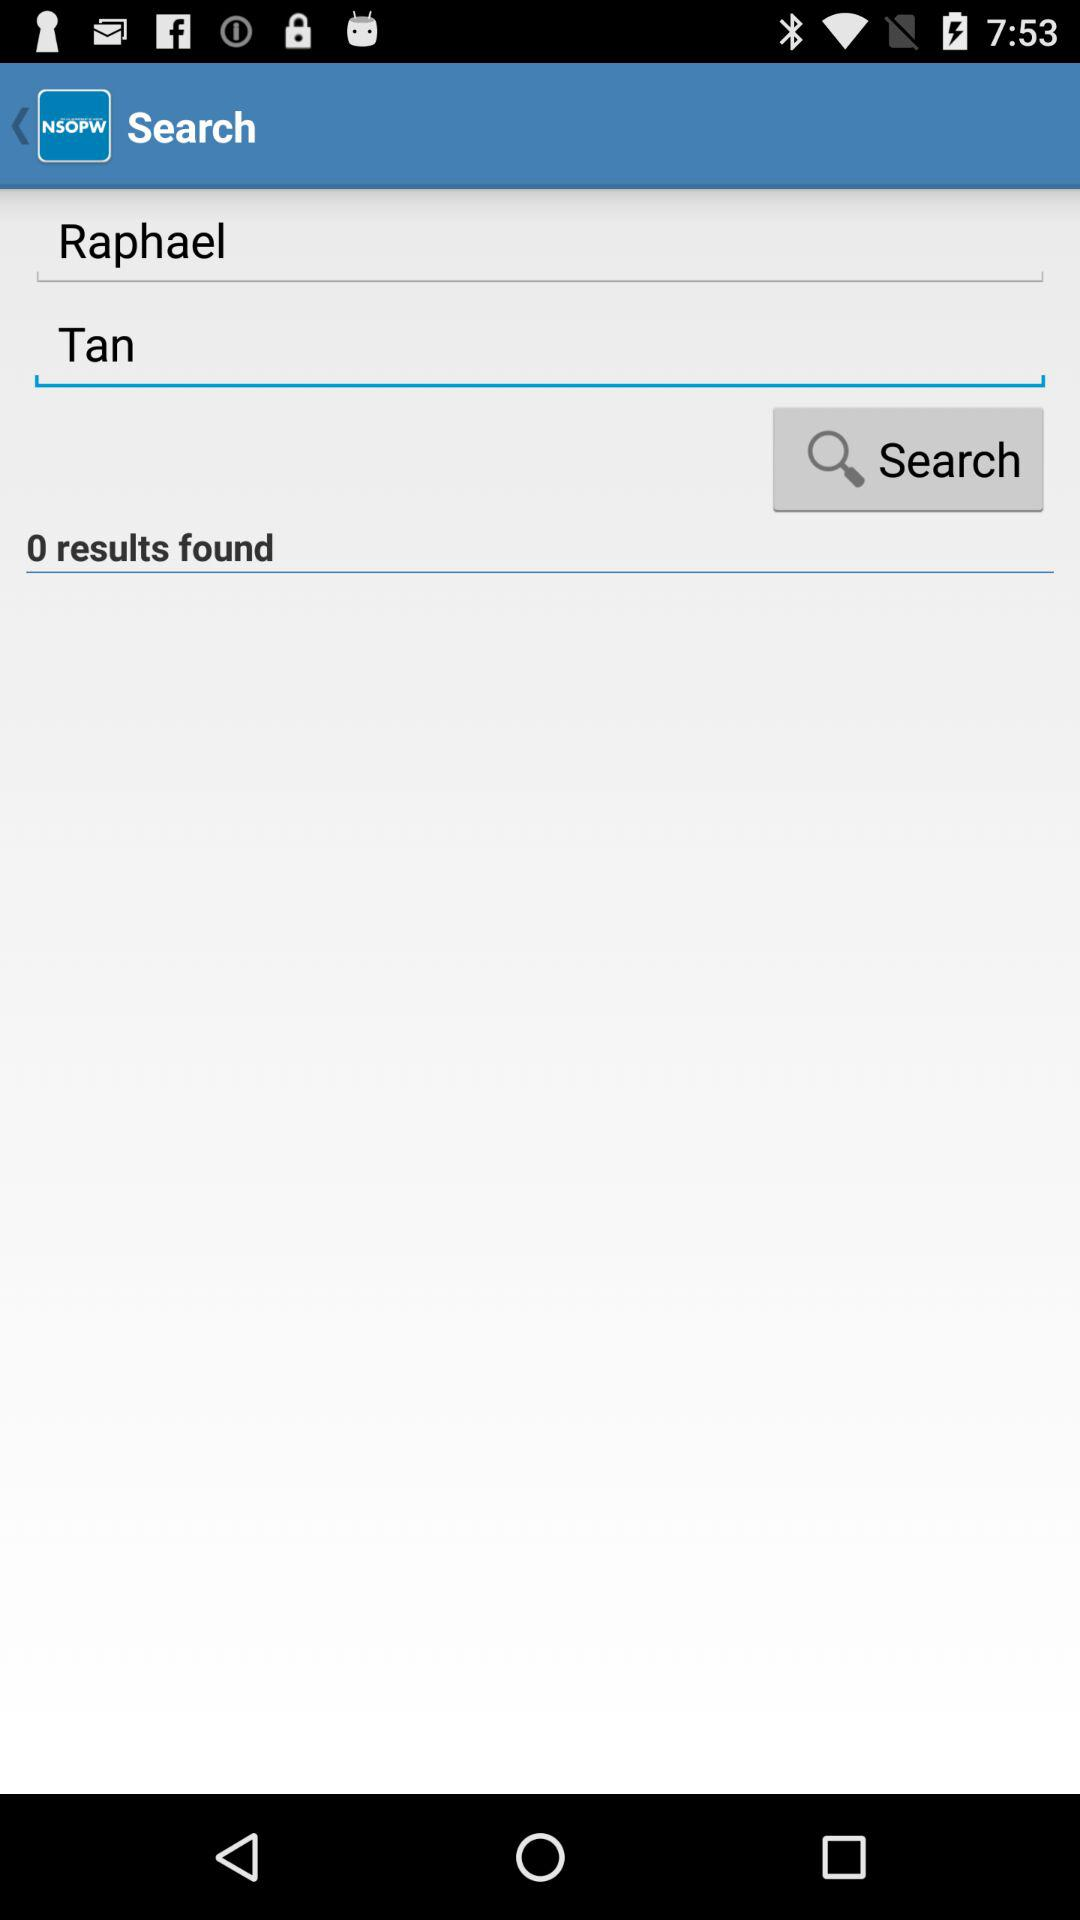How many results are there?
Answer the question using a single word or phrase. 0 